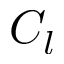Convert formula to latex. <formula><loc_0><loc_0><loc_500><loc_500>C _ { l }</formula> 